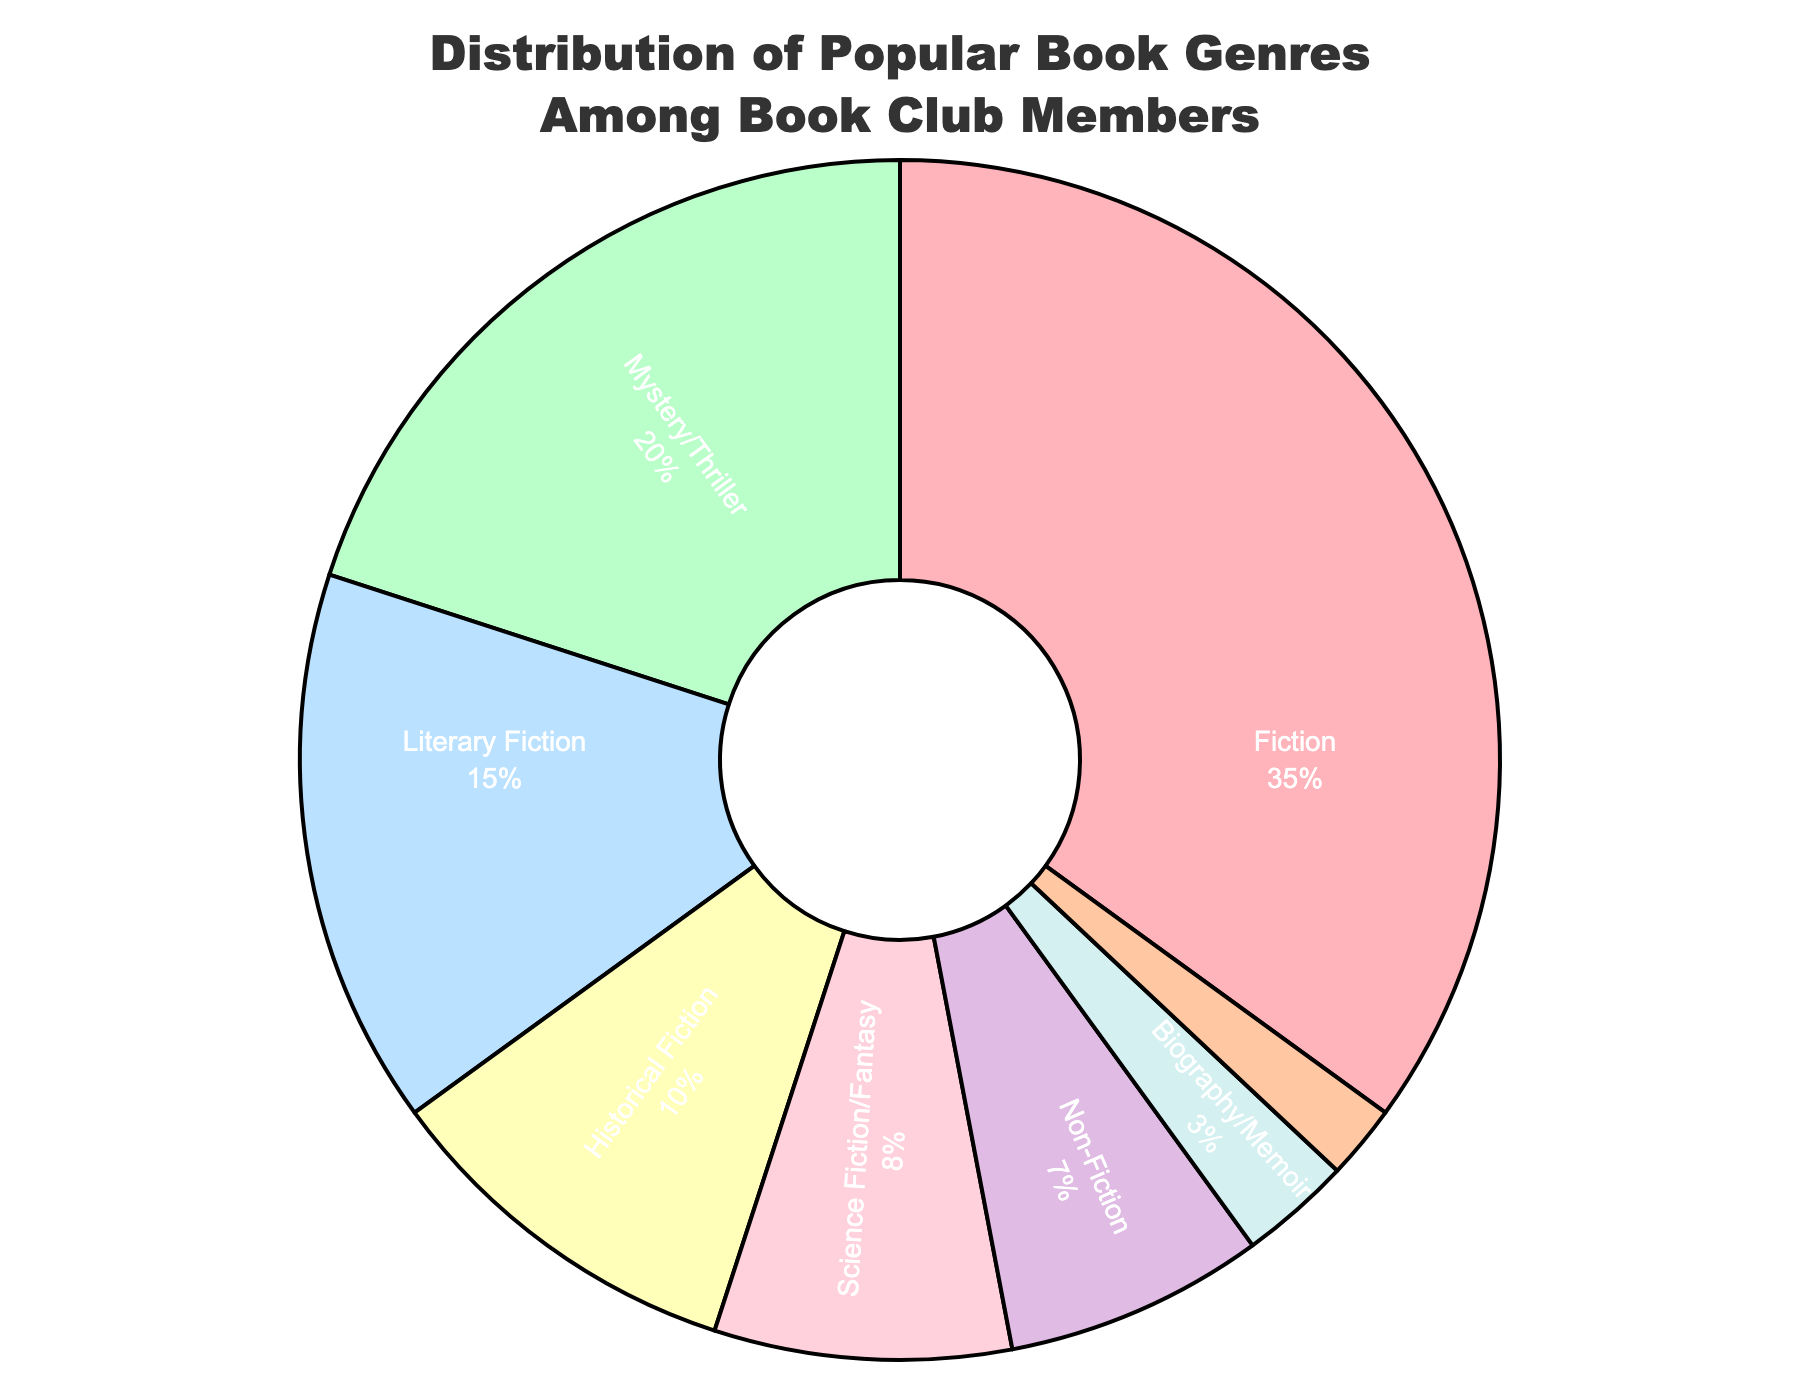what genre has the highest percentage? The chart shows each genre and its corresponding percentage. Fiction has the highest segment size of 35%.
Answer: Fiction what is the total percentage of Fiction and Mystery/Thriller combined? Add the percentages of Fiction (35%) and Mystery/Thriller (20%). 35% + 20% = 55%.
Answer: 55% What is the difference in percentage between Literary Fiction and Historical Fiction? Subtract the percentage of Historical Fiction (10%) from Literary Fiction (15%). 15% - 10% = 5%.
Answer: 5% How many genres have a percentage greater than 10%? Identify the genres and their percentages: Fiction (35%), Mystery/Thriller (20%), and Literary Fiction (15%) all have percentages greater than 10%. There are 3 such genres.
Answer: 3 Which genre has the smallest percentage? The smallest segment in the pie chart represents Romance, which has a percentage of 2%.
Answer: Romance What is the combined percentage of all non-fiction related genres (Non-Fiction, Biography/Memoir)? Add the percentages of Non-Fiction (7%) and Biography/Memoir (3%). 7% + 3% = 10%.
Answer: 10% How does the percentage of Science Fiction/Fantasy compare to Non-Fiction? Compare the percentages of Science Fiction/Fantasy (8%) and Non-Fiction (7%). Science Fiction/Fantasy has a 1% higher percentage than Non-Fiction.
Answer: Science Fiction/Fantasy is higher by 1% What is the sum of the percentages for genres with less than 10% each? Identify genres with percentages less than 10%: Science Fiction/Fantasy (8%), Non-Fiction (7%), Biography/Memoir (3%), and Romance (2%). Add their percentages: 8% + 7% + 3% + 2% = 20%.
Answer: 20% What percentage of the genres represented total 90%? To find the percentage that totals 90%, identify and sum the top genres in decreasing order until you reach or exceed 90%. Fiction (35%), Mystery/Thriller (20%), Literary Fiction (15%), and Historical Fiction (10%) sum up to 35% + 20% + 15% + 10% = 80%. Adding Science Fiction/Fantasy (8%) results in 88%. Thus, the genres combined are Fiction, Mystery/Thriller, Literary Fiction, Historical Fiction, and Science Fiction/Fantasy.
Answer: 88% 